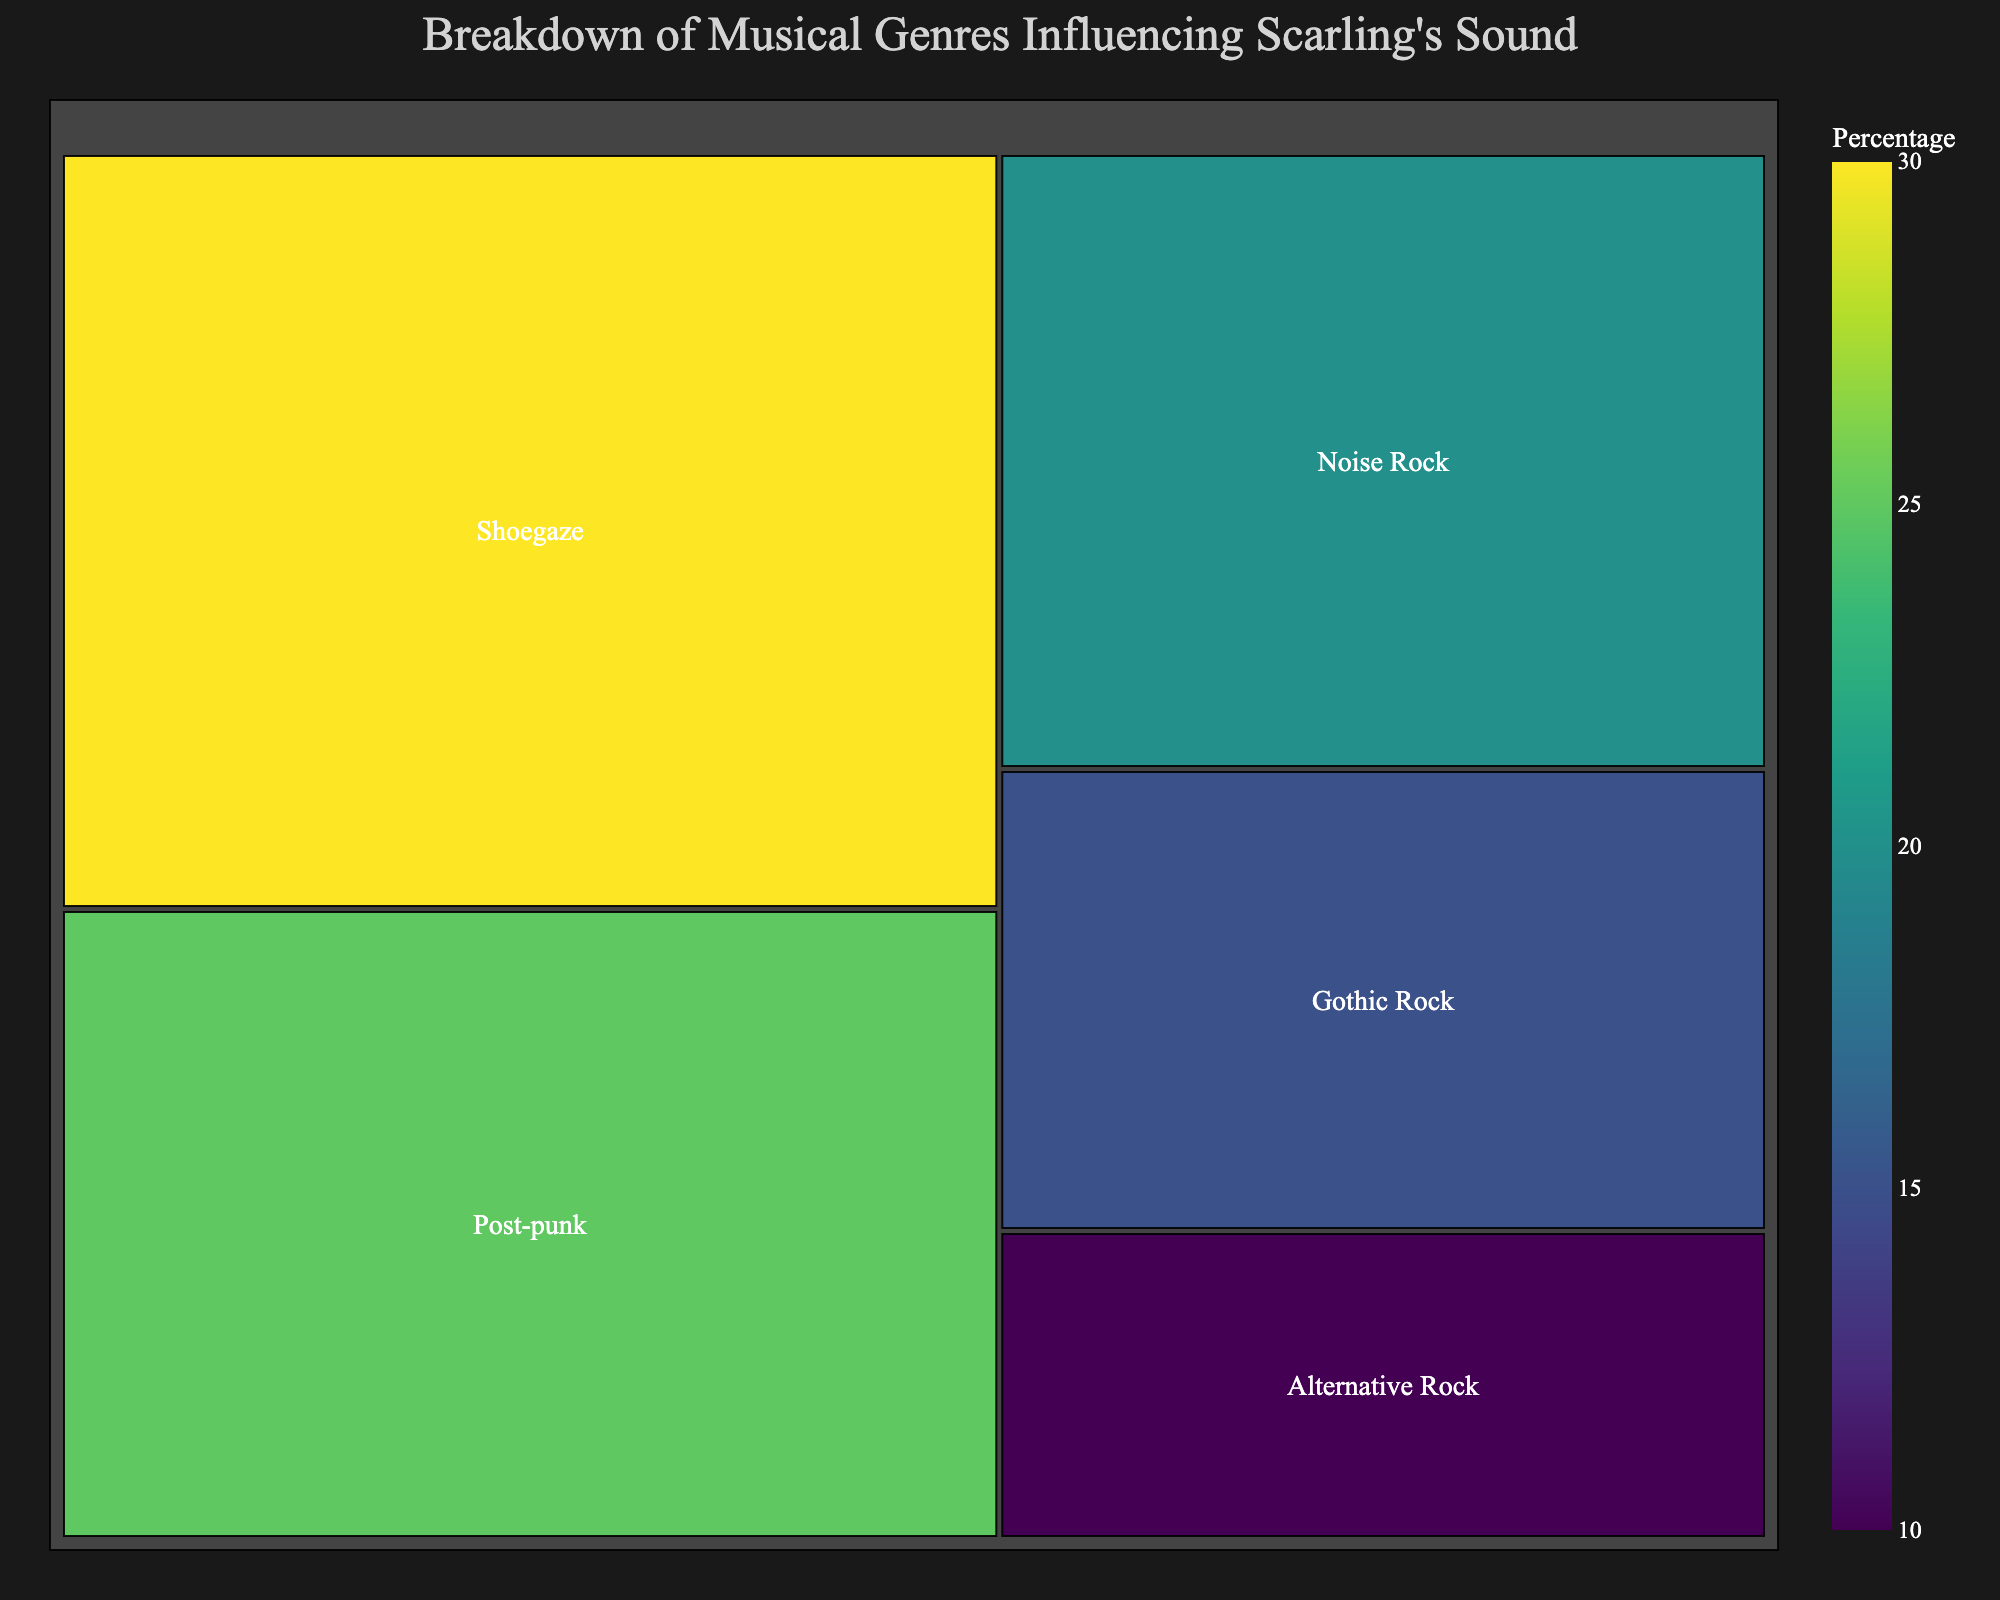What genre has the highest percentage influence on Scarling's sound? The genre with the highest percentage is Shoegaze, as it occupies the largest area in the treemap and is labeled with 30%.
Answer: Shoegaze Which genre has the least influence on Scarling's sound? The genre with the smallest percentage is Alternative Rock, which has the smallest section in the treemap and is labeled with 10%.
Answer: Alternative Rock What is the combined percentage for Post-punk and Noise Rock influences? The treemap shows Post-punk at 25% and Noise Rock at 20%. Adding these together gives 25% + 20% = 45%.
Answer: 45% Compare and determine if Post-punk's influence is greater or less than Gothic Rock's influence. According to the treemap, Post-punk has 25%, and Gothic Rock has 15%. Since 25% is greater than 15%, Post-punk's influence is greater.
Answer: Greater By how much does Shoegaze's influence exceed the combined influence of Gothic Rock and Alternative Rock? Shoegaze is 30%. Gothic Rock is 15% and Alternative Rock is 10%. Adding Gothic Rock and Alternative Rock gives 15% + 10% = 25%. The difference is 30% - 25% = 5%.
Answer: 5% Which genre has an influence closest to one-fourth of Scarling's sound? One-fourth is 25%. The treemap shows Post-punk has exactly 25%, so its influence is closest to one-fourth.
Answer: Post-punk How much larger is Noise Rock's percentage than Alternative Rock's percentage? Noise Rock has 20% and Alternative Rock has 10%. Subtracting these gives 20% - 10% = 10%.
Answer: 10% What effect does Gothic Rock have on Scarling's sound compared to Noise Rock? Gothic Rock has 15%, while Noise Rock has 20%. Since 20% is greater than 15%, Gothic Rock's influence is less than Noise Rock's.
Answer: Less What is the total percentage of the three genres with the lowest influence on Scarling's sound? The three genres with the lowest percentages are Noise Rock (20%), Gothic Rock (15%), and Alternative Rock (10%). Adding these together gives 20% + 15% + 10% = 45%.
Answer: 45% Determine the difference in influence between the genre with the highest percentage and the genre with the second-highest percentage. Shoegaze has the highest percentage at 30%, and Post-punk is second at 25%. The difference is 30% - 25% = 5%.
Answer: 5% 